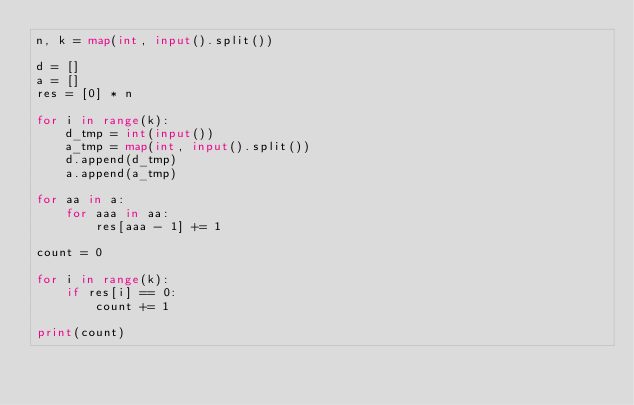Convert code to text. <code><loc_0><loc_0><loc_500><loc_500><_Python_>n, k = map(int, input().split())

d = []
a = []
res = [0] * n

for i in range(k):
    d_tmp = int(input())
    a_tmp = map(int, input().split())
    d.append(d_tmp)
    a.append(a_tmp)

for aa in a:
    for aaa in aa:
        res[aaa - 1] += 1

count = 0

for i in range(k):
    if res[i] == 0:
        count += 1

print(count)
</code> 